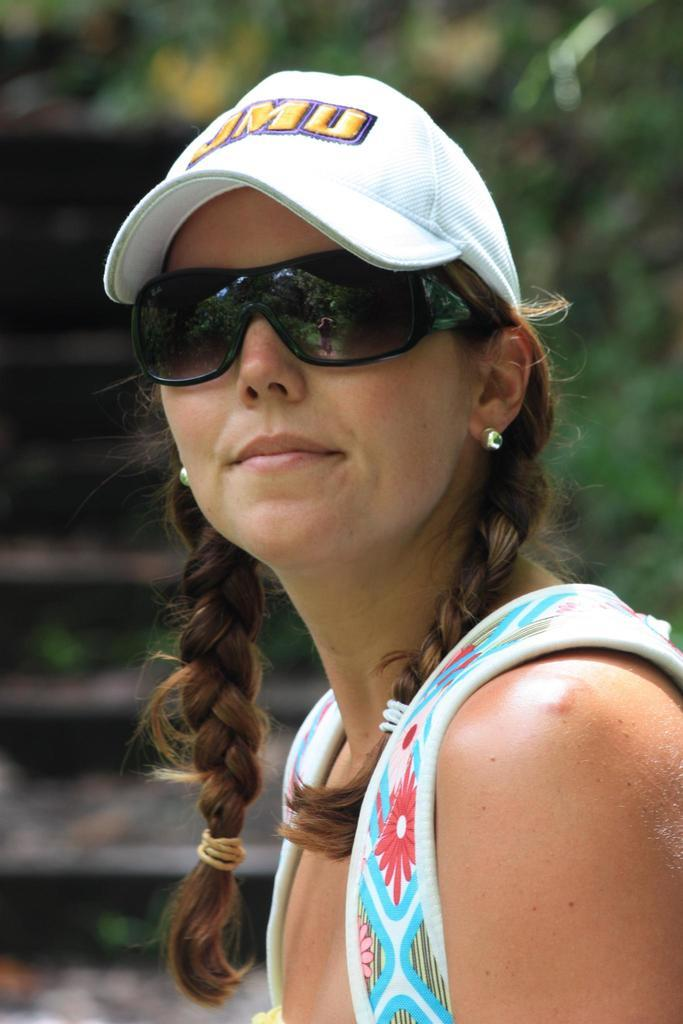Who is present in the image? There is a woman in the image. What is the woman wearing on her head? The woman is wearing a white hat. What type of eyewear is the woman wearing? The woman is wearing goggles. What can be seen in the background of the image? There are stairs and trees in the background of the image. How is the background of the image depicted? The background is blurred. What type of crate is visible in the image? There is no crate present in the image. How does the smoke affect the visibility in the image? There is no smoke present in the image, so it does not affect the visibility. 